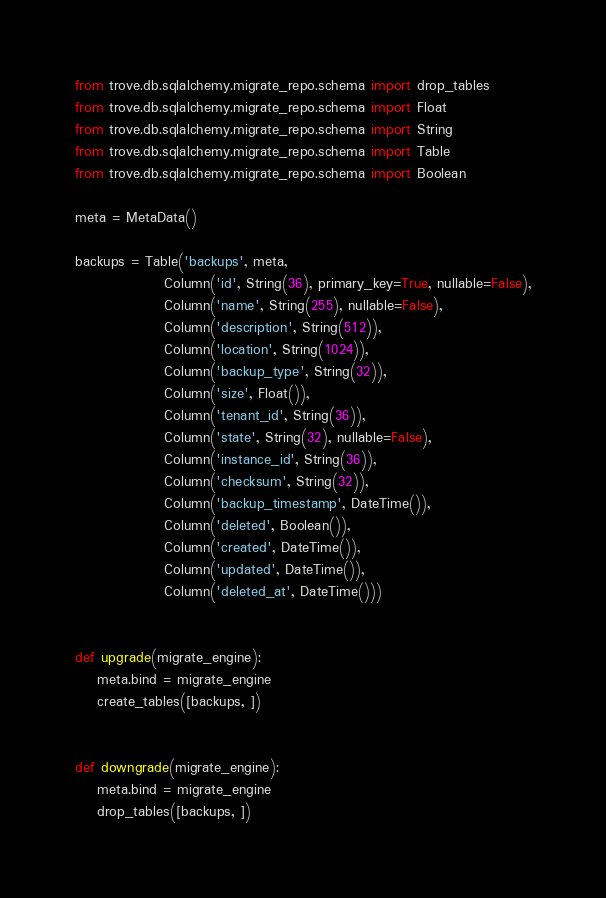Convert code to text. <code><loc_0><loc_0><loc_500><loc_500><_Python_>from trove.db.sqlalchemy.migrate_repo.schema import drop_tables
from trove.db.sqlalchemy.migrate_repo.schema import Float
from trove.db.sqlalchemy.migrate_repo.schema import String
from trove.db.sqlalchemy.migrate_repo.schema import Table
from trove.db.sqlalchemy.migrate_repo.schema import Boolean

meta = MetaData()

backups = Table('backups', meta,
                Column('id', String(36), primary_key=True, nullable=False),
                Column('name', String(255), nullable=False),
                Column('description', String(512)),
                Column('location', String(1024)),
                Column('backup_type', String(32)),
                Column('size', Float()),
                Column('tenant_id', String(36)),
                Column('state', String(32), nullable=False),
                Column('instance_id', String(36)),
                Column('checksum', String(32)),
                Column('backup_timestamp', DateTime()),
                Column('deleted', Boolean()),
                Column('created', DateTime()),
                Column('updated', DateTime()),
                Column('deleted_at', DateTime()))


def upgrade(migrate_engine):
    meta.bind = migrate_engine
    create_tables([backups, ])


def downgrade(migrate_engine):
    meta.bind = migrate_engine
    drop_tables([backups, ])
</code> 